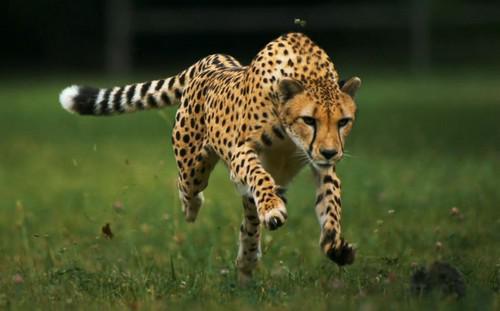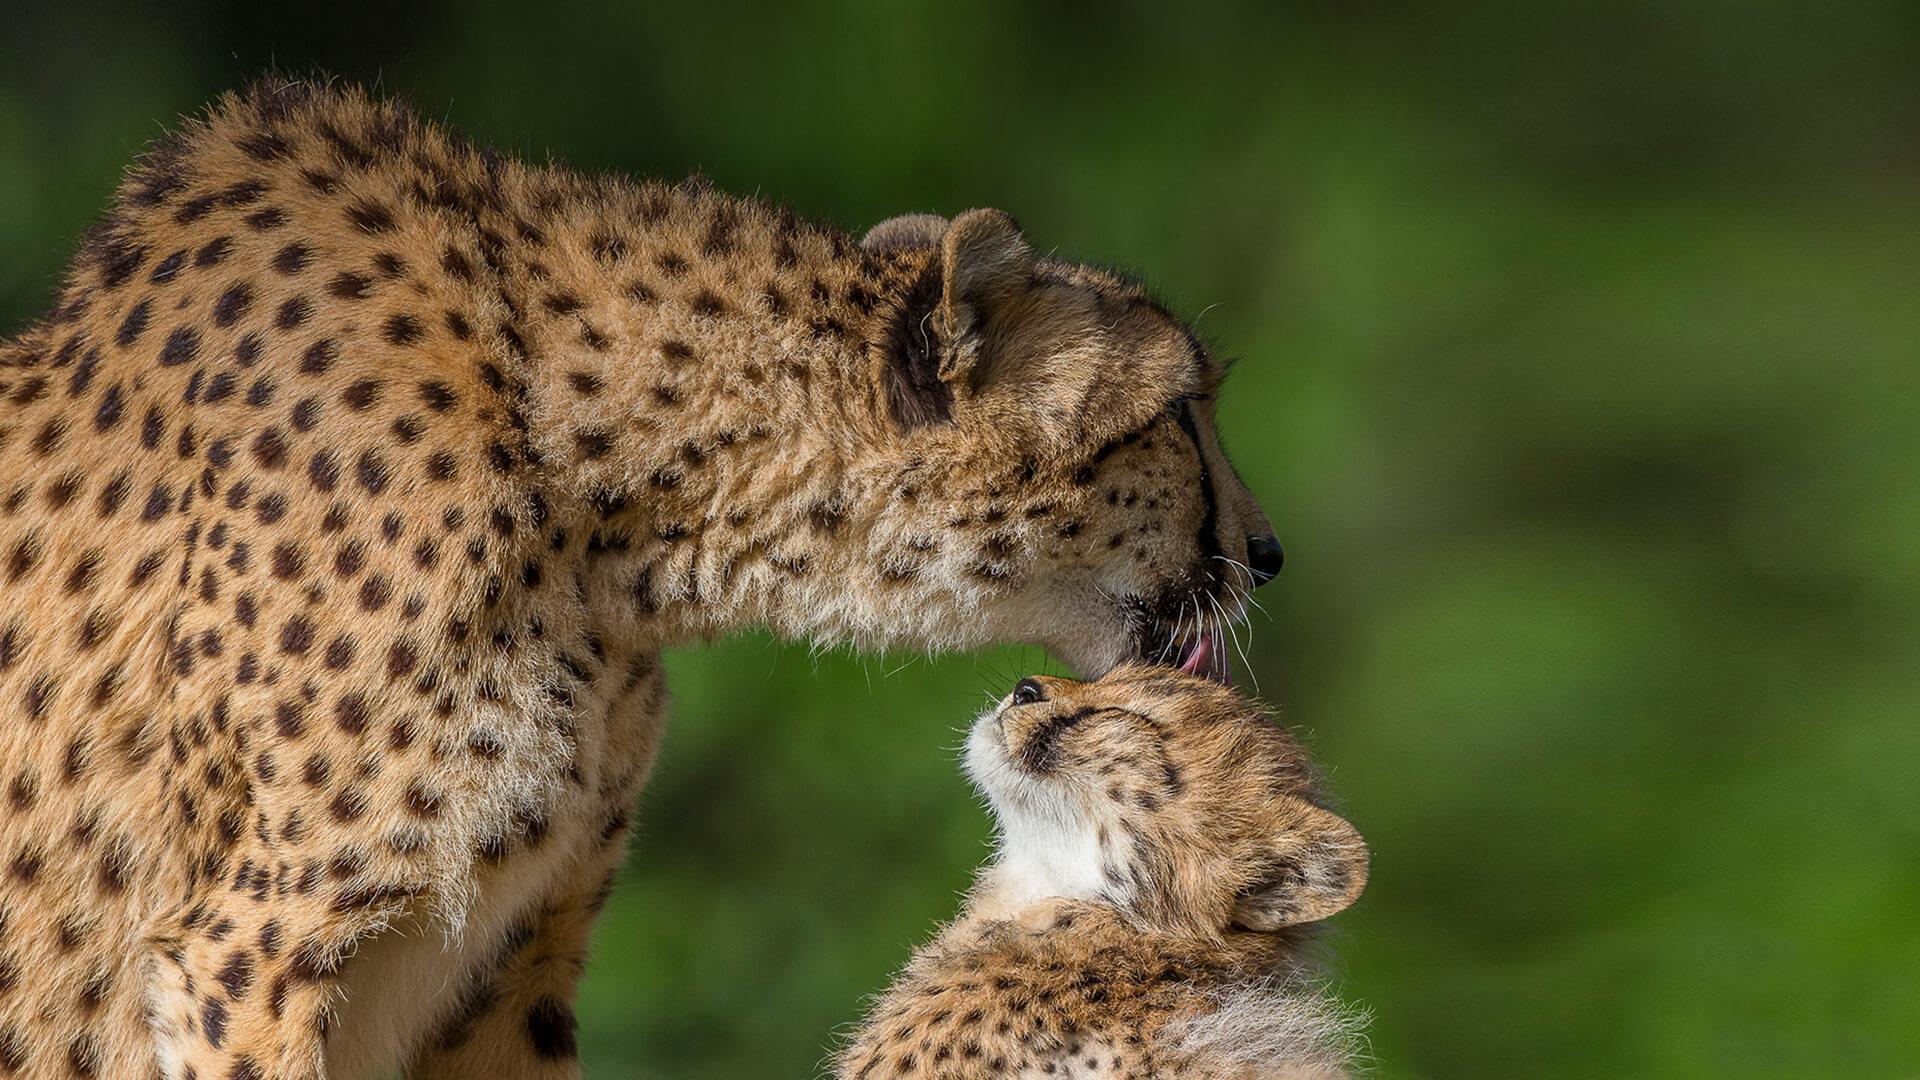The first image is the image on the left, the second image is the image on the right. Assess this claim about the two images: "Several animals are in a grassy are in the image on the left.". Correct or not? Answer yes or no. No. The first image is the image on the left, the second image is the image on the right. Given the left and right images, does the statement "Exactly three cheetahs are shown, with two in one image sedentary, and the third in the other image running with its front paws off the ground." hold true? Answer yes or no. Yes. 